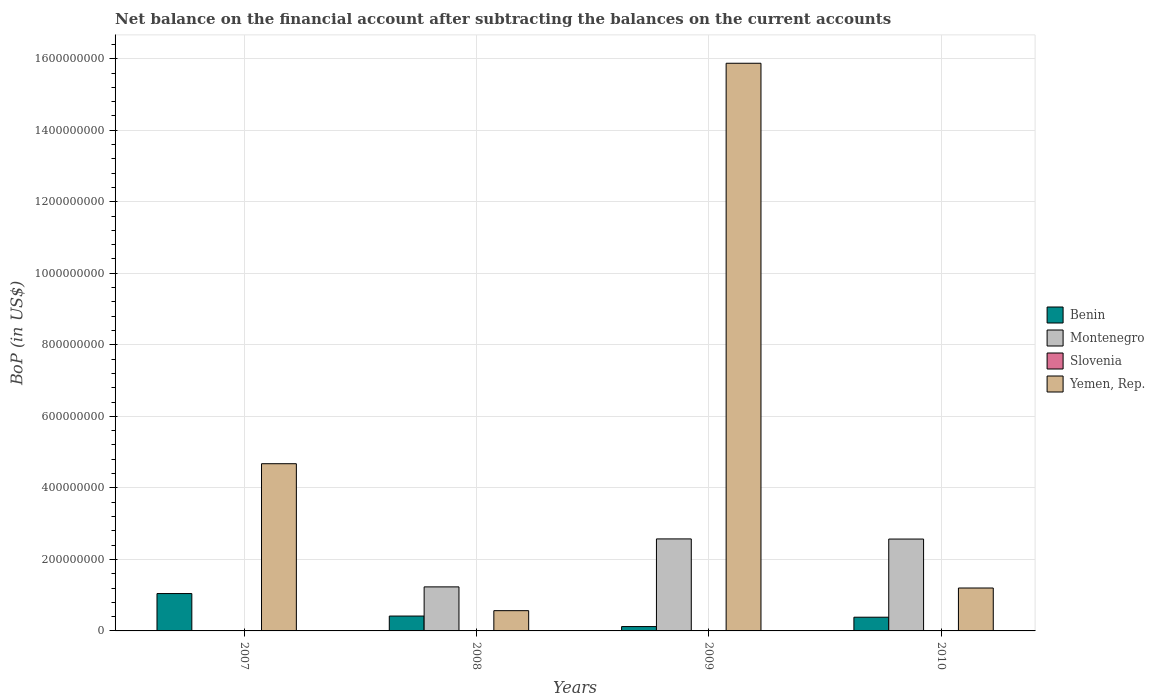Are the number of bars on each tick of the X-axis equal?
Provide a short and direct response. No. How many bars are there on the 1st tick from the left?
Offer a terse response. 2. What is the Balance of Payments in Slovenia in 2009?
Your answer should be compact. 0. Across all years, what is the maximum Balance of Payments in Benin?
Provide a short and direct response. 1.05e+08. Across all years, what is the minimum Balance of Payments in Benin?
Your answer should be very brief. 1.21e+07. What is the total Balance of Payments in Montenegro in the graph?
Offer a terse response. 6.37e+08. What is the difference between the Balance of Payments in Yemen, Rep. in 2008 and that in 2010?
Provide a short and direct response. -6.33e+07. What is the difference between the Balance of Payments in Yemen, Rep. in 2008 and the Balance of Payments in Montenegro in 2010?
Provide a succinct answer. -2.00e+08. What is the average Balance of Payments in Yemen, Rep. per year?
Offer a terse response. 5.58e+08. In the year 2010, what is the difference between the Balance of Payments in Benin and Balance of Payments in Montenegro?
Make the answer very short. -2.19e+08. In how many years, is the Balance of Payments in Benin greater than 80000000 US$?
Your answer should be compact. 1. What is the ratio of the Balance of Payments in Benin in 2007 to that in 2008?
Your answer should be very brief. 2.51. Is the Balance of Payments in Benin in 2009 less than that in 2010?
Provide a succinct answer. Yes. What is the difference between the highest and the second highest Balance of Payments in Benin?
Offer a very short reply. 6.29e+07. What is the difference between the highest and the lowest Balance of Payments in Montenegro?
Your answer should be compact. 2.57e+08. Is it the case that in every year, the sum of the Balance of Payments in Montenegro and Balance of Payments in Yemen, Rep. is greater than the sum of Balance of Payments in Slovenia and Balance of Payments in Benin?
Give a very brief answer. No. Is it the case that in every year, the sum of the Balance of Payments in Slovenia and Balance of Payments in Benin is greater than the Balance of Payments in Yemen, Rep.?
Keep it short and to the point. No. Are all the bars in the graph horizontal?
Your response must be concise. No. How many years are there in the graph?
Give a very brief answer. 4. Are the values on the major ticks of Y-axis written in scientific E-notation?
Your answer should be compact. No. Does the graph contain any zero values?
Your answer should be very brief. Yes. Does the graph contain grids?
Offer a terse response. Yes. Where does the legend appear in the graph?
Offer a terse response. Center right. How many legend labels are there?
Ensure brevity in your answer.  4. How are the legend labels stacked?
Offer a terse response. Vertical. What is the title of the graph?
Your answer should be very brief. Net balance on the financial account after subtracting the balances on the current accounts. Does "Europe(developing only)" appear as one of the legend labels in the graph?
Provide a short and direct response. No. What is the label or title of the X-axis?
Ensure brevity in your answer.  Years. What is the label or title of the Y-axis?
Keep it short and to the point. BoP (in US$). What is the BoP (in US$) in Benin in 2007?
Make the answer very short. 1.05e+08. What is the BoP (in US$) in Yemen, Rep. in 2007?
Provide a succinct answer. 4.68e+08. What is the BoP (in US$) in Benin in 2008?
Offer a terse response. 4.16e+07. What is the BoP (in US$) in Montenegro in 2008?
Give a very brief answer. 1.23e+08. What is the BoP (in US$) in Yemen, Rep. in 2008?
Offer a terse response. 5.66e+07. What is the BoP (in US$) in Benin in 2009?
Keep it short and to the point. 1.21e+07. What is the BoP (in US$) in Montenegro in 2009?
Your answer should be compact. 2.57e+08. What is the BoP (in US$) in Slovenia in 2009?
Keep it short and to the point. 0. What is the BoP (in US$) of Yemen, Rep. in 2009?
Your response must be concise. 1.59e+09. What is the BoP (in US$) in Benin in 2010?
Your answer should be very brief. 3.83e+07. What is the BoP (in US$) in Montenegro in 2010?
Give a very brief answer. 2.57e+08. What is the BoP (in US$) of Slovenia in 2010?
Your answer should be very brief. 0. What is the BoP (in US$) of Yemen, Rep. in 2010?
Offer a terse response. 1.20e+08. Across all years, what is the maximum BoP (in US$) of Benin?
Offer a terse response. 1.05e+08. Across all years, what is the maximum BoP (in US$) in Montenegro?
Provide a succinct answer. 2.57e+08. Across all years, what is the maximum BoP (in US$) of Yemen, Rep.?
Your answer should be compact. 1.59e+09. Across all years, what is the minimum BoP (in US$) of Benin?
Ensure brevity in your answer.  1.21e+07. Across all years, what is the minimum BoP (in US$) in Montenegro?
Give a very brief answer. 0. Across all years, what is the minimum BoP (in US$) in Yemen, Rep.?
Offer a terse response. 5.66e+07. What is the total BoP (in US$) in Benin in the graph?
Give a very brief answer. 1.97e+08. What is the total BoP (in US$) in Montenegro in the graph?
Make the answer very short. 6.37e+08. What is the total BoP (in US$) of Yemen, Rep. in the graph?
Your answer should be very brief. 2.23e+09. What is the difference between the BoP (in US$) in Benin in 2007 and that in 2008?
Provide a succinct answer. 6.29e+07. What is the difference between the BoP (in US$) of Yemen, Rep. in 2007 and that in 2008?
Ensure brevity in your answer.  4.11e+08. What is the difference between the BoP (in US$) of Benin in 2007 and that in 2009?
Your answer should be very brief. 9.24e+07. What is the difference between the BoP (in US$) of Yemen, Rep. in 2007 and that in 2009?
Your answer should be very brief. -1.12e+09. What is the difference between the BoP (in US$) of Benin in 2007 and that in 2010?
Ensure brevity in your answer.  6.62e+07. What is the difference between the BoP (in US$) of Yemen, Rep. in 2007 and that in 2010?
Provide a short and direct response. 3.48e+08. What is the difference between the BoP (in US$) in Benin in 2008 and that in 2009?
Ensure brevity in your answer.  2.94e+07. What is the difference between the BoP (in US$) in Montenegro in 2008 and that in 2009?
Offer a very short reply. -1.34e+08. What is the difference between the BoP (in US$) in Yemen, Rep. in 2008 and that in 2009?
Ensure brevity in your answer.  -1.53e+09. What is the difference between the BoP (in US$) of Benin in 2008 and that in 2010?
Offer a terse response. 3.22e+06. What is the difference between the BoP (in US$) in Montenegro in 2008 and that in 2010?
Give a very brief answer. -1.34e+08. What is the difference between the BoP (in US$) of Yemen, Rep. in 2008 and that in 2010?
Provide a succinct answer. -6.33e+07. What is the difference between the BoP (in US$) of Benin in 2009 and that in 2010?
Provide a succinct answer. -2.62e+07. What is the difference between the BoP (in US$) in Montenegro in 2009 and that in 2010?
Keep it short and to the point. 3.79e+05. What is the difference between the BoP (in US$) of Yemen, Rep. in 2009 and that in 2010?
Offer a very short reply. 1.47e+09. What is the difference between the BoP (in US$) in Benin in 2007 and the BoP (in US$) in Montenegro in 2008?
Offer a very short reply. -1.86e+07. What is the difference between the BoP (in US$) of Benin in 2007 and the BoP (in US$) of Yemen, Rep. in 2008?
Offer a very short reply. 4.79e+07. What is the difference between the BoP (in US$) of Benin in 2007 and the BoP (in US$) of Montenegro in 2009?
Ensure brevity in your answer.  -1.53e+08. What is the difference between the BoP (in US$) of Benin in 2007 and the BoP (in US$) of Yemen, Rep. in 2009?
Offer a very short reply. -1.48e+09. What is the difference between the BoP (in US$) in Benin in 2007 and the BoP (in US$) in Montenegro in 2010?
Your answer should be compact. -1.52e+08. What is the difference between the BoP (in US$) of Benin in 2007 and the BoP (in US$) of Yemen, Rep. in 2010?
Make the answer very short. -1.55e+07. What is the difference between the BoP (in US$) of Benin in 2008 and the BoP (in US$) of Montenegro in 2009?
Provide a succinct answer. -2.16e+08. What is the difference between the BoP (in US$) of Benin in 2008 and the BoP (in US$) of Yemen, Rep. in 2009?
Give a very brief answer. -1.55e+09. What is the difference between the BoP (in US$) in Montenegro in 2008 and the BoP (in US$) in Yemen, Rep. in 2009?
Give a very brief answer. -1.46e+09. What is the difference between the BoP (in US$) of Benin in 2008 and the BoP (in US$) of Montenegro in 2010?
Your answer should be compact. -2.15e+08. What is the difference between the BoP (in US$) in Benin in 2008 and the BoP (in US$) in Yemen, Rep. in 2010?
Make the answer very short. -7.84e+07. What is the difference between the BoP (in US$) of Montenegro in 2008 and the BoP (in US$) of Yemen, Rep. in 2010?
Your answer should be compact. 3.16e+06. What is the difference between the BoP (in US$) of Benin in 2009 and the BoP (in US$) of Montenegro in 2010?
Offer a terse response. -2.45e+08. What is the difference between the BoP (in US$) of Benin in 2009 and the BoP (in US$) of Yemen, Rep. in 2010?
Offer a terse response. -1.08e+08. What is the difference between the BoP (in US$) of Montenegro in 2009 and the BoP (in US$) of Yemen, Rep. in 2010?
Your response must be concise. 1.37e+08. What is the average BoP (in US$) in Benin per year?
Offer a terse response. 4.91e+07. What is the average BoP (in US$) in Montenegro per year?
Make the answer very short. 1.59e+08. What is the average BoP (in US$) of Slovenia per year?
Keep it short and to the point. 0. What is the average BoP (in US$) in Yemen, Rep. per year?
Provide a short and direct response. 5.58e+08. In the year 2007, what is the difference between the BoP (in US$) in Benin and BoP (in US$) in Yemen, Rep.?
Give a very brief answer. -3.63e+08. In the year 2008, what is the difference between the BoP (in US$) in Benin and BoP (in US$) in Montenegro?
Make the answer very short. -8.16e+07. In the year 2008, what is the difference between the BoP (in US$) in Benin and BoP (in US$) in Yemen, Rep.?
Ensure brevity in your answer.  -1.51e+07. In the year 2008, what is the difference between the BoP (in US$) in Montenegro and BoP (in US$) in Yemen, Rep.?
Your answer should be compact. 6.65e+07. In the year 2009, what is the difference between the BoP (in US$) of Benin and BoP (in US$) of Montenegro?
Your answer should be compact. -2.45e+08. In the year 2009, what is the difference between the BoP (in US$) of Benin and BoP (in US$) of Yemen, Rep.?
Your answer should be very brief. -1.58e+09. In the year 2009, what is the difference between the BoP (in US$) in Montenegro and BoP (in US$) in Yemen, Rep.?
Your answer should be compact. -1.33e+09. In the year 2010, what is the difference between the BoP (in US$) in Benin and BoP (in US$) in Montenegro?
Your answer should be very brief. -2.19e+08. In the year 2010, what is the difference between the BoP (in US$) of Benin and BoP (in US$) of Yemen, Rep.?
Give a very brief answer. -8.16e+07. In the year 2010, what is the difference between the BoP (in US$) in Montenegro and BoP (in US$) in Yemen, Rep.?
Keep it short and to the point. 1.37e+08. What is the ratio of the BoP (in US$) in Benin in 2007 to that in 2008?
Offer a terse response. 2.51. What is the ratio of the BoP (in US$) of Yemen, Rep. in 2007 to that in 2008?
Your answer should be very brief. 8.26. What is the ratio of the BoP (in US$) in Benin in 2007 to that in 2009?
Make the answer very short. 8.6. What is the ratio of the BoP (in US$) of Yemen, Rep. in 2007 to that in 2009?
Give a very brief answer. 0.29. What is the ratio of the BoP (in US$) in Benin in 2007 to that in 2010?
Make the answer very short. 2.73. What is the ratio of the BoP (in US$) in Yemen, Rep. in 2007 to that in 2010?
Your response must be concise. 3.9. What is the ratio of the BoP (in US$) in Benin in 2008 to that in 2009?
Provide a short and direct response. 3.42. What is the ratio of the BoP (in US$) in Montenegro in 2008 to that in 2009?
Your answer should be very brief. 0.48. What is the ratio of the BoP (in US$) of Yemen, Rep. in 2008 to that in 2009?
Keep it short and to the point. 0.04. What is the ratio of the BoP (in US$) of Benin in 2008 to that in 2010?
Provide a succinct answer. 1.08. What is the ratio of the BoP (in US$) of Montenegro in 2008 to that in 2010?
Provide a short and direct response. 0.48. What is the ratio of the BoP (in US$) in Yemen, Rep. in 2008 to that in 2010?
Keep it short and to the point. 0.47. What is the ratio of the BoP (in US$) of Benin in 2009 to that in 2010?
Make the answer very short. 0.32. What is the ratio of the BoP (in US$) of Yemen, Rep. in 2009 to that in 2010?
Provide a short and direct response. 13.23. What is the difference between the highest and the second highest BoP (in US$) in Benin?
Your answer should be compact. 6.29e+07. What is the difference between the highest and the second highest BoP (in US$) in Montenegro?
Provide a short and direct response. 3.79e+05. What is the difference between the highest and the second highest BoP (in US$) in Yemen, Rep.?
Your answer should be very brief. 1.12e+09. What is the difference between the highest and the lowest BoP (in US$) of Benin?
Offer a very short reply. 9.24e+07. What is the difference between the highest and the lowest BoP (in US$) of Montenegro?
Provide a short and direct response. 2.57e+08. What is the difference between the highest and the lowest BoP (in US$) in Yemen, Rep.?
Give a very brief answer. 1.53e+09. 